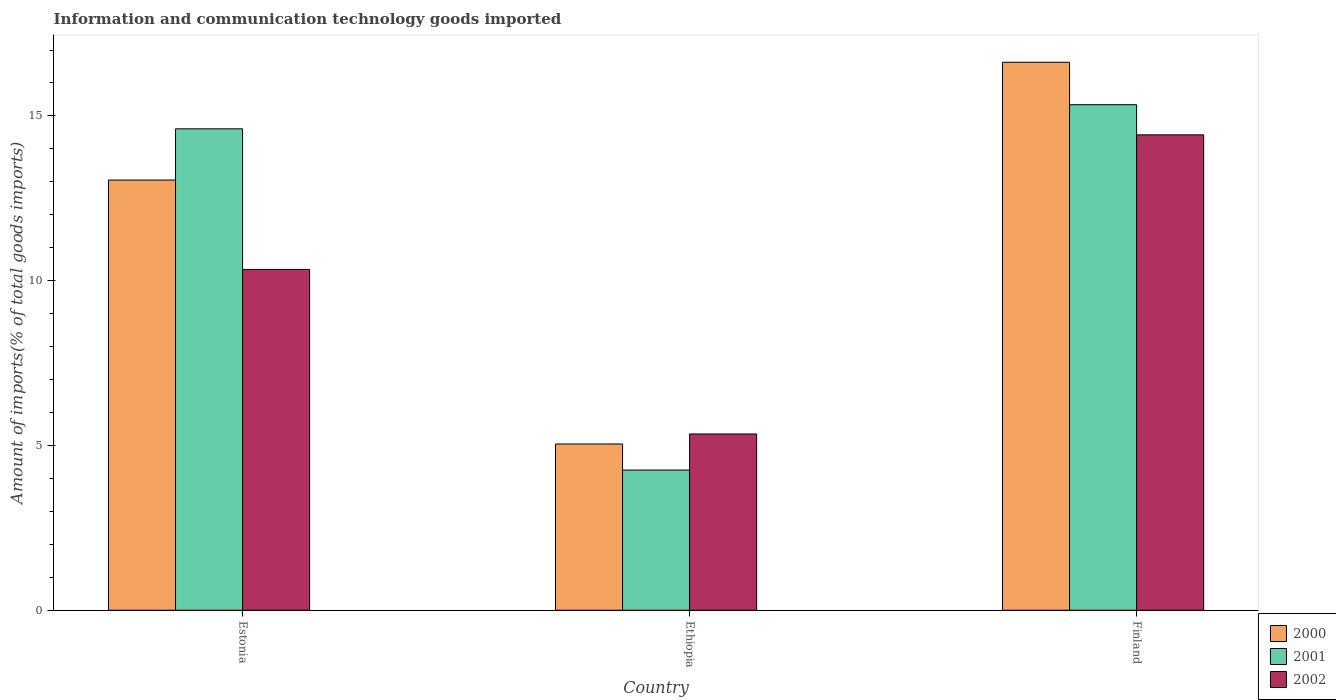How many groups of bars are there?
Your response must be concise. 3. Are the number of bars on each tick of the X-axis equal?
Ensure brevity in your answer.  Yes. How many bars are there on the 3rd tick from the left?
Provide a short and direct response. 3. How many bars are there on the 2nd tick from the right?
Keep it short and to the point. 3. What is the label of the 1st group of bars from the left?
Give a very brief answer. Estonia. What is the amount of goods imported in 2000 in Estonia?
Offer a terse response. 13.05. Across all countries, what is the maximum amount of goods imported in 2001?
Your answer should be very brief. 15.34. Across all countries, what is the minimum amount of goods imported in 2000?
Keep it short and to the point. 5.05. In which country was the amount of goods imported in 2001 minimum?
Make the answer very short. Ethiopia. What is the total amount of goods imported in 2000 in the graph?
Ensure brevity in your answer.  34.73. What is the difference between the amount of goods imported in 2000 in Estonia and that in Ethiopia?
Offer a terse response. 8.01. What is the difference between the amount of goods imported in 2000 in Ethiopia and the amount of goods imported in 2001 in Finland?
Provide a short and direct response. -10.29. What is the average amount of goods imported in 2001 per country?
Your response must be concise. 11.4. What is the difference between the amount of goods imported of/in 2000 and amount of goods imported of/in 2001 in Ethiopia?
Provide a short and direct response. 0.79. What is the ratio of the amount of goods imported in 2001 in Estonia to that in Ethiopia?
Offer a terse response. 3.43. Is the difference between the amount of goods imported in 2000 in Ethiopia and Finland greater than the difference between the amount of goods imported in 2001 in Ethiopia and Finland?
Keep it short and to the point. No. What is the difference between the highest and the second highest amount of goods imported in 2001?
Give a very brief answer. -10.35. What is the difference between the highest and the lowest amount of goods imported in 2002?
Provide a short and direct response. 9.08. In how many countries, is the amount of goods imported in 2000 greater than the average amount of goods imported in 2000 taken over all countries?
Offer a very short reply. 2. Is the sum of the amount of goods imported in 2001 in Estonia and Ethiopia greater than the maximum amount of goods imported in 2000 across all countries?
Ensure brevity in your answer.  Yes. What does the 1st bar from the left in Ethiopia represents?
Your response must be concise. 2000. Is it the case that in every country, the sum of the amount of goods imported in 2000 and amount of goods imported in 2001 is greater than the amount of goods imported in 2002?
Ensure brevity in your answer.  Yes. Are the values on the major ticks of Y-axis written in scientific E-notation?
Ensure brevity in your answer.  No. Does the graph contain grids?
Offer a very short reply. No. Where does the legend appear in the graph?
Keep it short and to the point. Bottom right. How many legend labels are there?
Provide a short and direct response. 3. What is the title of the graph?
Offer a very short reply. Information and communication technology goods imported. What is the label or title of the X-axis?
Give a very brief answer. Country. What is the label or title of the Y-axis?
Ensure brevity in your answer.  Amount of imports(% of total goods imports). What is the Amount of imports(% of total goods imports) in 2000 in Estonia?
Your answer should be compact. 13.05. What is the Amount of imports(% of total goods imports) of 2001 in Estonia?
Offer a terse response. 14.61. What is the Amount of imports(% of total goods imports) in 2002 in Estonia?
Offer a very short reply. 10.34. What is the Amount of imports(% of total goods imports) in 2000 in Ethiopia?
Provide a succinct answer. 5.05. What is the Amount of imports(% of total goods imports) of 2001 in Ethiopia?
Ensure brevity in your answer.  4.25. What is the Amount of imports(% of total goods imports) in 2002 in Ethiopia?
Provide a short and direct response. 5.35. What is the Amount of imports(% of total goods imports) in 2000 in Finland?
Offer a very short reply. 16.63. What is the Amount of imports(% of total goods imports) in 2001 in Finland?
Provide a succinct answer. 15.34. What is the Amount of imports(% of total goods imports) in 2002 in Finland?
Provide a succinct answer. 14.43. Across all countries, what is the maximum Amount of imports(% of total goods imports) in 2000?
Keep it short and to the point. 16.63. Across all countries, what is the maximum Amount of imports(% of total goods imports) in 2001?
Your response must be concise. 15.34. Across all countries, what is the maximum Amount of imports(% of total goods imports) of 2002?
Your answer should be compact. 14.43. Across all countries, what is the minimum Amount of imports(% of total goods imports) of 2000?
Make the answer very short. 5.05. Across all countries, what is the minimum Amount of imports(% of total goods imports) in 2001?
Provide a short and direct response. 4.25. Across all countries, what is the minimum Amount of imports(% of total goods imports) of 2002?
Your answer should be very brief. 5.35. What is the total Amount of imports(% of total goods imports) of 2000 in the graph?
Your answer should be very brief. 34.73. What is the total Amount of imports(% of total goods imports) in 2001 in the graph?
Make the answer very short. 34.2. What is the total Amount of imports(% of total goods imports) in 2002 in the graph?
Your answer should be very brief. 30.12. What is the difference between the Amount of imports(% of total goods imports) of 2000 in Estonia and that in Ethiopia?
Keep it short and to the point. 8.01. What is the difference between the Amount of imports(% of total goods imports) in 2001 in Estonia and that in Ethiopia?
Offer a terse response. 10.35. What is the difference between the Amount of imports(% of total goods imports) of 2002 in Estonia and that in Ethiopia?
Make the answer very short. 4.99. What is the difference between the Amount of imports(% of total goods imports) in 2000 in Estonia and that in Finland?
Ensure brevity in your answer.  -3.57. What is the difference between the Amount of imports(% of total goods imports) of 2001 in Estonia and that in Finland?
Ensure brevity in your answer.  -0.73. What is the difference between the Amount of imports(% of total goods imports) in 2002 in Estonia and that in Finland?
Keep it short and to the point. -4.08. What is the difference between the Amount of imports(% of total goods imports) of 2000 in Ethiopia and that in Finland?
Provide a short and direct response. -11.58. What is the difference between the Amount of imports(% of total goods imports) of 2001 in Ethiopia and that in Finland?
Provide a short and direct response. -11.09. What is the difference between the Amount of imports(% of total goods imports) in 2002 in Ethiopia and that in Finland?
Your answer should be compact. -9.08. What is the difference between the Amount of imports(% of total goods imports) of 2000 in Estonia and the Amount of imports(% of total goods imports) of 2001 in Ethiopia?
Your response must be concise. 8.8. What is the difference between the Amount of imports(% of total goods imports) in 2000 in Estonia and the Amount of imports(% of total goods imports) in 2002 in Ethiopia?
Offer a very short reply. 7.71. What is the difference between the Amount of imports(% of total goods imports) of 2001 in Estonia and the Amount of imports(% of total goods imports) of 2002 in Ethiopia?
Your answer should be compact. 9.26. What is the difference between the Amount of imports(% of total goods imports) of 2000 in Estonia and the Amount of imports(% of total goods imports) of 2001 in Finland?
Provide a succinct answer. -2.29. What is the difference between the Amount of imports(% of total goods imports) in 2000 in Estonia and the Amount of imports(% of total goods imports) in 2002 in Finland?
Give a very brief answer. -1.37. What is the difference between the Amount of imports(% of total goods imports) in 2001 in Estonia and the Amount of imports(% of total goods imports) in 2002 in Finland?
Ensure brevity in your answer.  0.18. What is the difference between the Amount of imports(% of total goods imports) of 2000 in Ethiopia and the Amount of imports(% of total goods imports) of 2001 in Finland?
Give a very brief answer. -10.29. What is the difference between the Amount of imports(% of total goods imports) of 2000 in Ethiopia and the Amount of imports(% of total goods imports) of 2002 in Finland?
Your answer should be compact. -9.38. What is the difference between the Amount of imports(% of total goods imports) of 2001 in Ethiopia and the Amount of imports(% of total goods imports) of 2002 in Finland?
Your answer should be very brief. -10.17. What is the average Amount of imports(% of total goods imports) of 2000 per country?
Keep it short and to the point. 11.58. What is the average Amount of imports(% of total goods imports) in 2001 per country?
Offer a very short reply. 11.4. What is the average Amount of imports(% of total goods imports) in 2002 per country?
Give a very brief answer. 10.04. What is the difference between the Amount of imports(% of total goods imports) in 2000 and Amount of imports(% of total goods imports) in 2001 in Estonia?
Your answer should be compact. -1.55. What is the difference between the Amount of imports(% of total goods imports) of 2000 and Amount of imports(% of total goods imports) of 2002 in Estonia?
Make the answer very short. 2.71. What is the difference between the Amount of imports(% of total goods imports) of 2001 and Amount of imports(% of total goods imports) of 2002 in Estonia?
Keep it short and to the point. 4.27. What is the difference between the Amount of imports(% of total goods imports) of 2000 and Amount of imports(% of total goods imports) of 2001 in Ethiopia?
Ensure brevity in your answer.  0.79. What is the difference between the Amount of imports(% of total goods imports) of 2000 and Amount of imports(% of total goods imports) of 2002 in Ethiopia?
Offer a very short reply. -0.3. What is the difference between the Amount of imports(% of total goods imports) in 2001 and Amount of imports(% of total goods imports) in 2002 in Ethiopia?
Give a very brief answer. -1.09. What is the difference between the Amount of imports(% of total goods imports) of 2000 and Amount of imports(% of total goods imports) of 2001 in Finland?
Offer a terse response. 1.29. What is the difference between the Amount of imports(% of total goods imports) of 2000 and Amount of imports(% of total goods imports) of 2002 in Finland?
Give a very brief answer. 2.2. What is the difference between the Amount of imports(% of total goods imports) in 2001 and Amount of imports(% of total goods imports) in 2002 in Finland?
Offer a very short reply. 0.91. What is the ratio of the Amount of imports(% of total goods imports) in 2000 in Estonia to that in Ethiopia?
Offer a very short reply. 2.59. What is the ratio of the Amount of imports(% of total goods imports) in 2001 in Estonia to that in Ethiopia?
Keep it short and to the point. 3.43. What is the ratio of the Amount of imports(% of total goods imports) in 2002 in Estonia to that in Ethiopia?
Provide a succinct answer. 1.93. What is the ratio of the Amount of imports(% of total goods imports) in 2000 in Estonia to that in Finland?
Provide a succinct answer. 0.79. What is the ratio of the Amount of imports(% of total goods imports) of 2001 in Estonia to that in Finland?
Make the answer very short. 0.95. What is the ratio of the Amount of imports(% of total goods imports) of 2002 in Estonia to that in Finland?
Make the answer very short. 0.72. What is the ratio of the Amount of imports(% of total goods imports) of 2000 in Ethiopia to that in Finland?
Your response must be concise. 0.3. What is the ratio of the Amount of imports(% of total goods imports) in 2001 in Ethiopia to that in Finland?
Keep it short and to the point. 0.28. What is the ratio of the Amount of imports(% of total goods imports) in 2002 in Ethiopia to that in Finland?
Your response must be concise. 0.37. What is the difference between the highest and the second highest Amount of imports(% of total goods imports) in 2000?
Your answer should be compact. 3.57. What is the difference between the highest and the second highest Amount of imports(% of total goods imports) in 2001?
Offer a terse response. 0.73. What is the difference between the highest and the second highest Amount of imports(% of total goods imports) of 2002?
Provide a short and direct response. 4.08. What is the difference between the highest and the lowest Amount of imports(% of total goods imports) of 2000?
Keep it short and to the point. 11.58. What is the difference between the highest and the lowest Amount of imports(% of total goods imports) of 2001?
Ensure brevity in your answer.  11.09. What is the difference between the highest and the lowest Amount of imports(% of total goods imports) of 2002?
Make the answer very short. 9.08. 